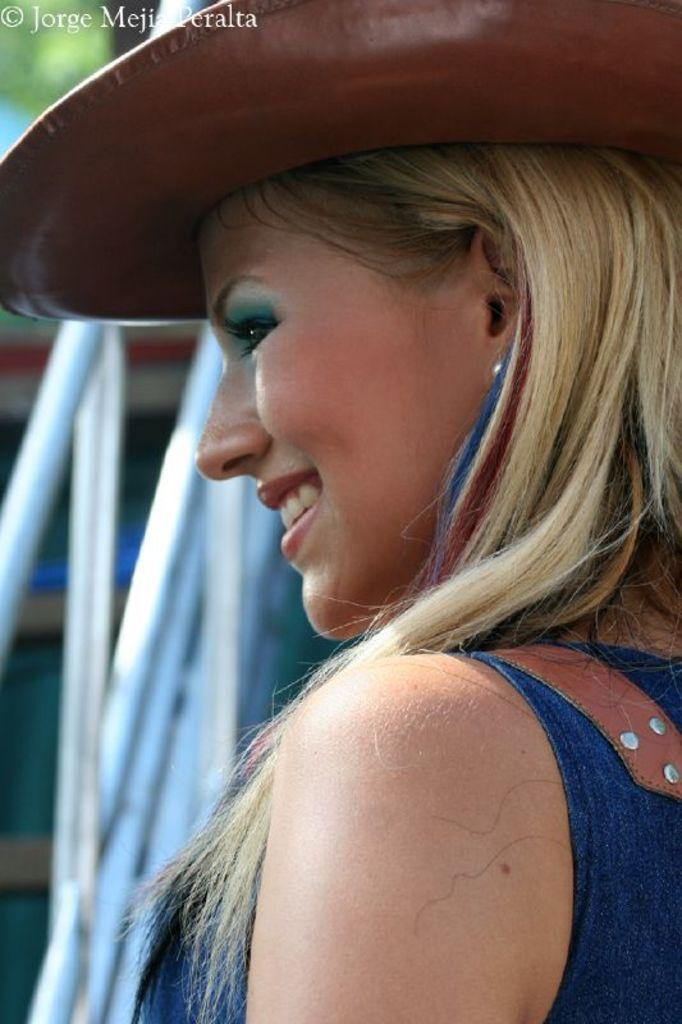What is the main subject of the image? The main subject of the image is a woman. What is the woman wearing on her head? The woman is wearing a hat. What type of edge can be seen on the pies in the image? There are no pies present in the image, so there is no edge to be seen. 